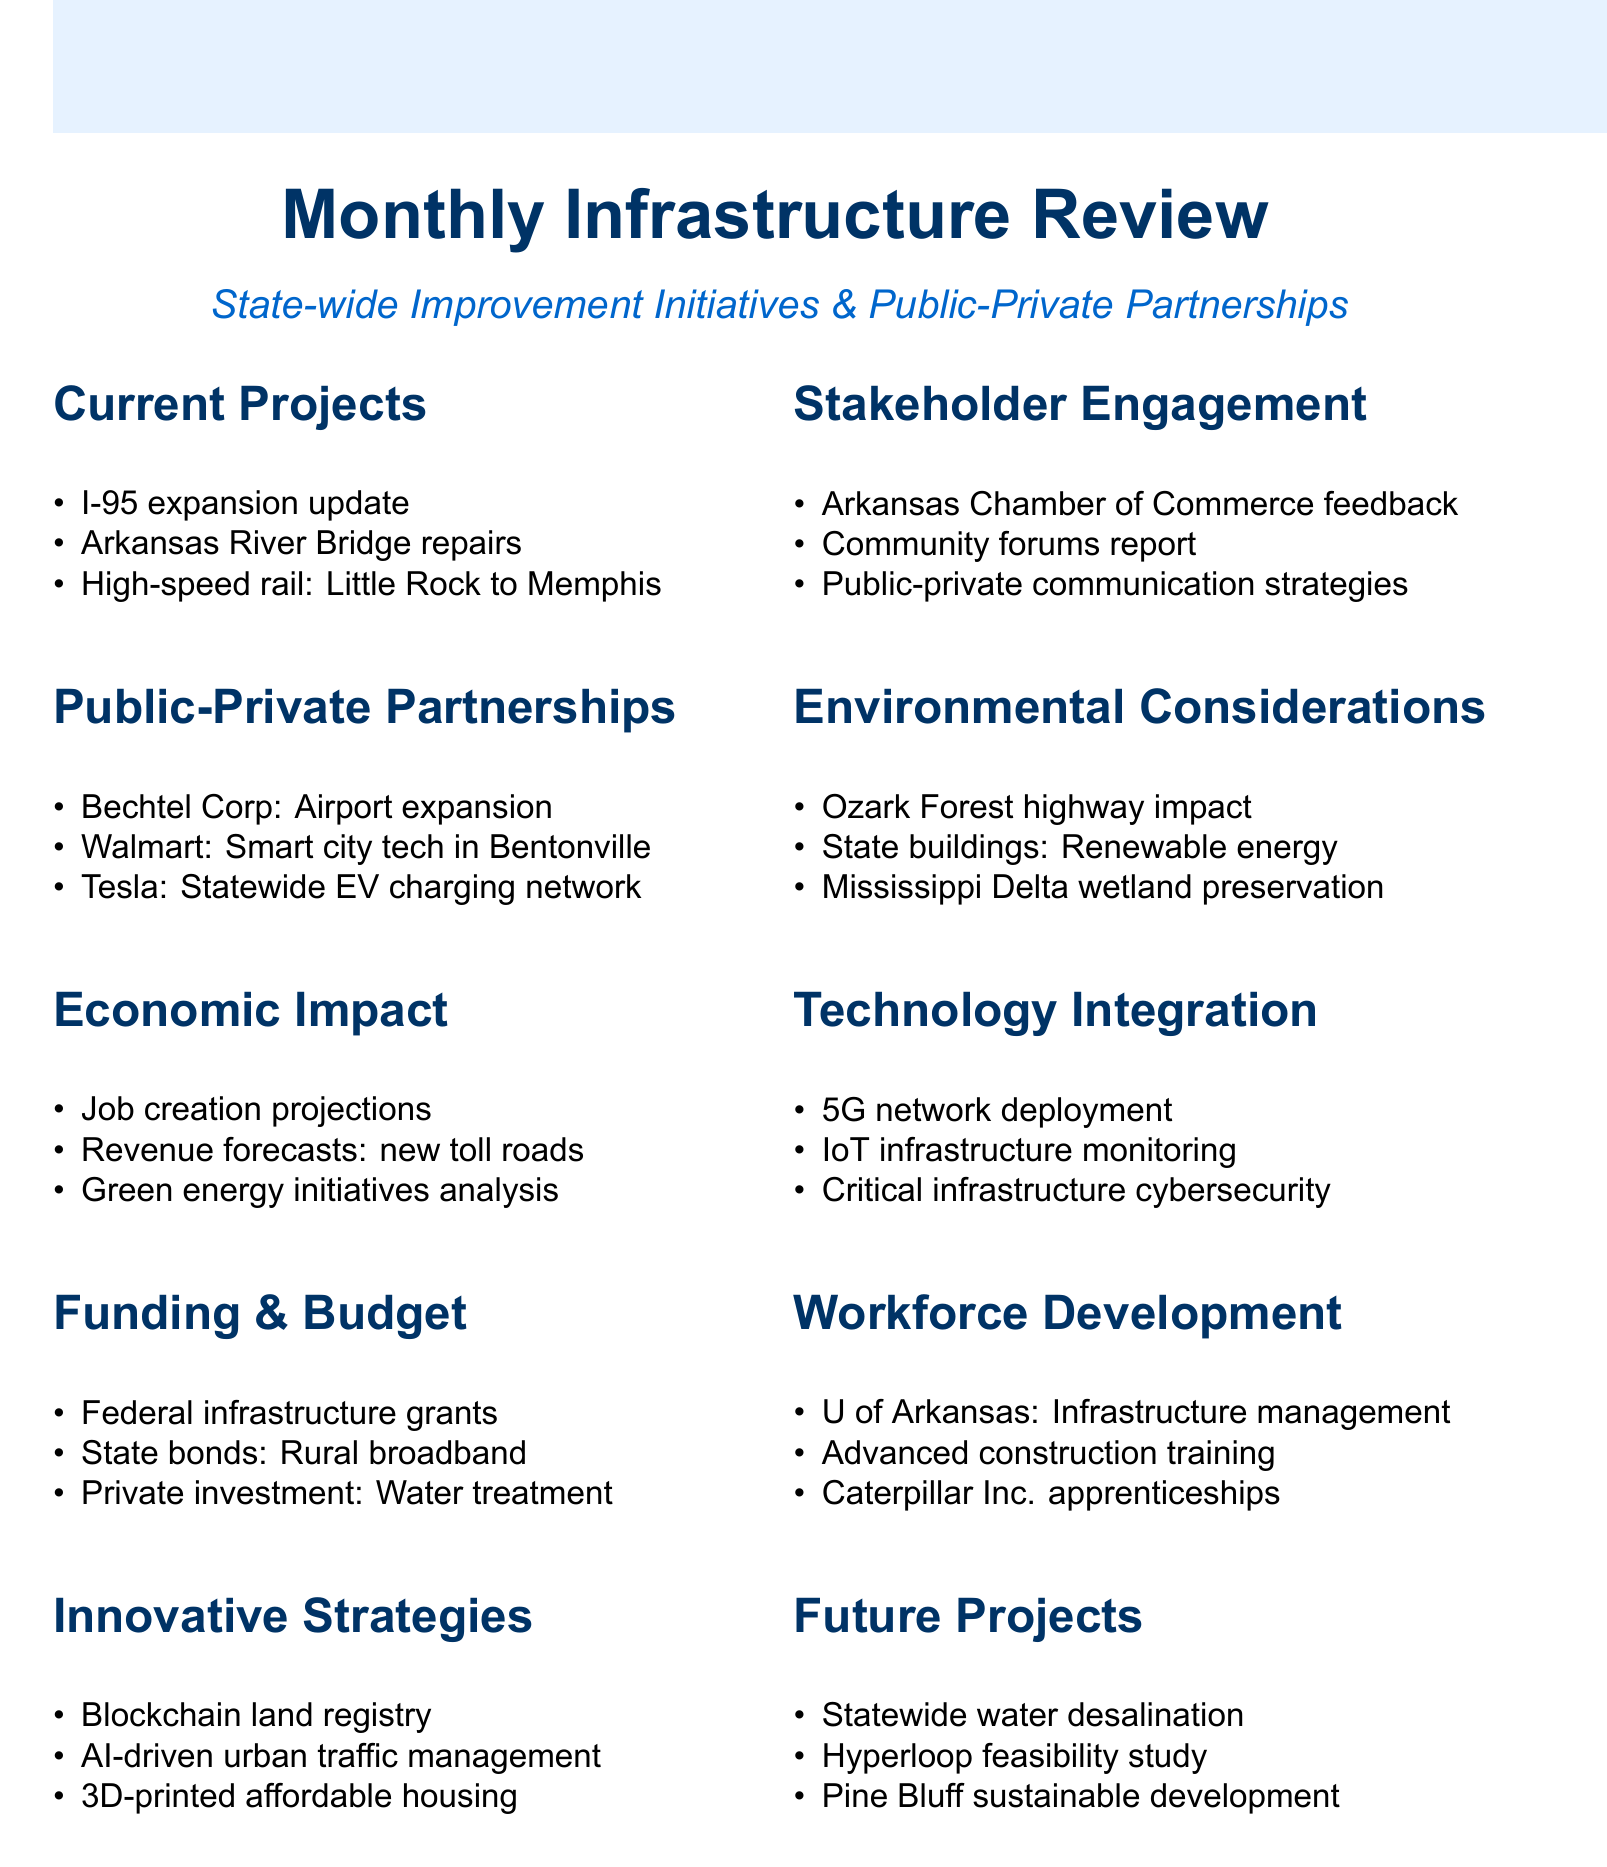What is the current project related to I-95? The current project related to I-95 is the expansion update.
Answer: I-95 expansion update Who presented on the potential airport expansion? The Bechtel Corporation presented on the potential airport expansion.
Answer: Bechtel Corporation What is the focus of Walmart's proposal? Walmart's proposal focuses on smart city technologies in Bentonville.
Answer: smart city technologies in Bentonville What is the job creation projection type mentioned? The job creation projection type mentioned is from ongoing projects.
Answer: ongoing projects What is one innovative strategy discussed in the document? One innovative strategy discussed in the document is a blockchain-based land registry system.
Answer: blockchain-based land registry system How many community forums were held according to the stakeholder engagement section? The document mentions community forums held in Little Rock, Fayetteville, and Jonesboro, indicating three locations.
Answer: three What environmental effort is mentioned in the Mississippi Delta region? The environmental effort mentioned is wetland preservation.
Answer: wetland preservation What update was given regarding 5G networks? The update given was on 5G network deployment across the state.
Answer: 5G network deployment What educational partnership is included in workforce development? The educational partnership included is with the University of Arkansas for infrastructure management courses.
Answer: University of Arkansas for infrastructure management courses 